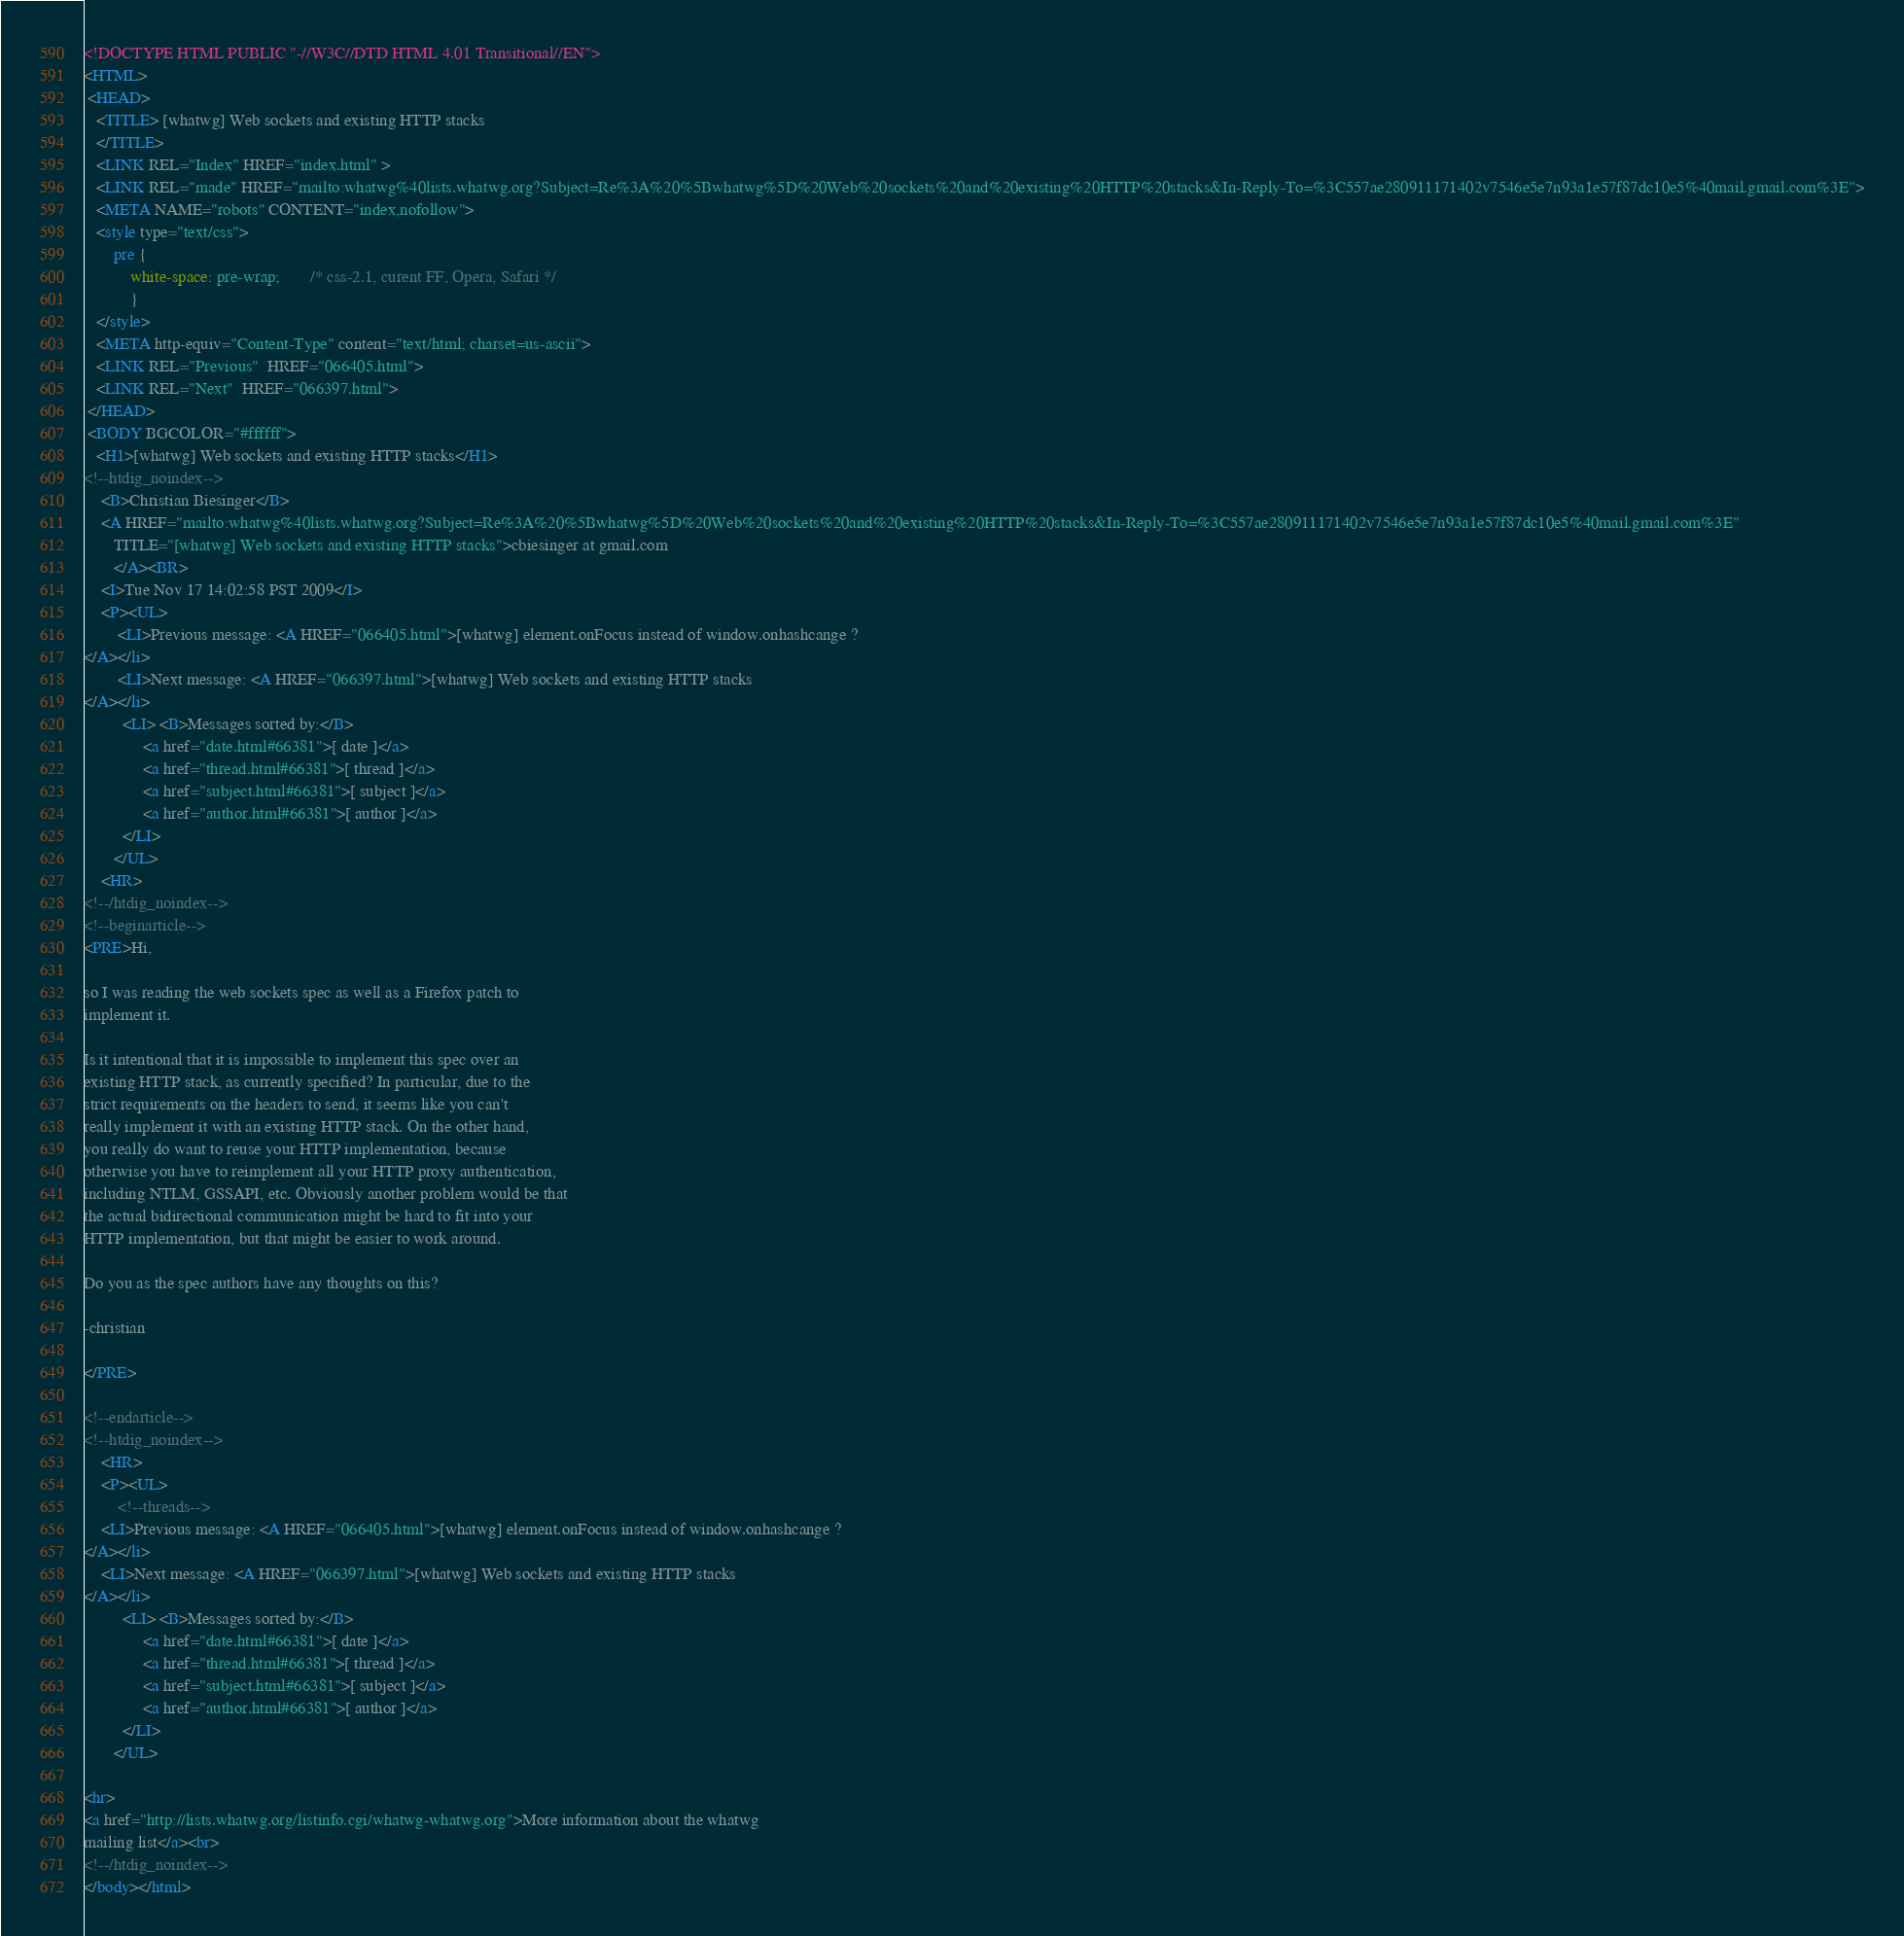<code> <loc_0><loc_0><loc_500><loc_500><_HTML_><!DOCTYPE HTML PUBLIC "-//W3C//DTD HTML 4.01 Transitional//EN">
<HTML>
 <HEAD>
   <TITLE> [whatwg] Web sockets and existing HTTP stacks
   </TITLE>
   <LINK REL="Index" HREF="index.html" >
   <LINK REL="made" HREF="mailto:whatwg%40lists.whatwg.org?Subject=Re%3A%20%5Bwhatwg%5D%20Web%20sockets%20and%20existing%20HTTP%20stacks&In-Reply-To=%3C557ae280911171402v7546e5e7n93a1e57f87dc10e5%40mail.gmail.com%3E">
   <META NAME="robots" CONTENT="index,nofollow">
   <style type="text/css">
       pre {
           white-space: pre-wrap;       /* css-2.1, curent FF, Opera, Safari */
           }
   </style>
   <META http-equiv="Content-Type" content="text/html; charset=us-ascii">
   <LINK REL="Previous"  HREF="066405.html">
   <LINK REL="Next"  HREF="066397.html">
 </HEAD>
 <BODY BGCOLOR="#ffffff">
   <H1>[whatwg] Web sockets and existing HTTP stacks</H1>
<!--htdig_noindex-->
    <B>Christian Biesinger</B> 
    <A HREF="mailto:whatwg%40lists.whatwg.org?Subject=Re%3A%20%5Bwhatwg%5D%20Web%20sockets%20and%20existing%20HTTP%20stacks&In-Reply-To=%3C557ae280911171402v7546e5e7n93a1e57f87dc10e5%40mail.gmail.com%3E"
       TITLE="[whatwg] Web sockets and existing HTTP stacks">cbiesinger at gmail.com
       </A><BR>
    <I>Tue Nov 17 14:02:58 PST 2009</I>
    <P><UL>
        <LI>Previous message: <A HREF="066405.html">[whatwg] element.onFocus instead of window.onhashcange ?
</A></li>
        <LI>Next message: <A HREF="066397.html">[whatwg] Web sockets and existing HTTP stacks
</A></li>
         <LI> <B>Messages sorted by:</B> 
              <a href="date.html#66381">[ date ]</a>
              <a href="thread.html#66381">[ thread ]</a>
              <a href="subject.html#66381">[ subject ]</a>
              <a href="author.html#66381">[ author ]</a>
         </LI>
       </UL>
    <HR>  
<!--/htdig_noindex-->
<!--beginarticle-->
<PRE>Hi,

so I was reading the web sockets spec as well as a Firefox patch to
implement it.

Is it intentional that it is impossible to implement this spec over an
existing HTTP stack, as currently specified? In particular, due to the
strict requirements on the headers to send, it seems like you can't
really implement it with an existing HTTP stack. On the other hand,
you really do want to reuse your HTTP implementation, because
otherwise you have to reimplement all your HTTP proxy authentication,
including NTLM, GSSAPI, etc. Obviously another problem would be that
the actual bidirectional communication might be hard to fit into your
HTTP implementation, but that might be easier to work around.

Do you as the spec authors have any thoughts on this?

-christian

</PRE>

<!--endarticle-->
<!--htdig_noindex-->
    <HR>
    <P><UL>
        <!--threads-->
	<LI>Previous message: <A HREF="066405.html">[whatwg] element.onFocus instead of window.onhashcange ?
</A></li>
	<LI>Next message: <A HREF="066397.html">[whatwg] Web sockets and existing HTTP stacks
</A></li>
         <LI> <B>Messages sorted by:</B> 
              <a href="date.html#66381">[ date ]</a>
              <a href="thread.html#66381">[ thread ]</a>
              <a href="subject.html#66381">[ subject ]</a>
              <a href="author.html#66381">[ author ]</a>
         </LI>
       </UL>

<hr>
<a href="http://lists.whatwg.org/listinfo.cgi/whatwg-whatwg.org">More information about the whatwg
mailing list</a><br>
<!--/htdig_noindex-->
</body></html>
</code> 